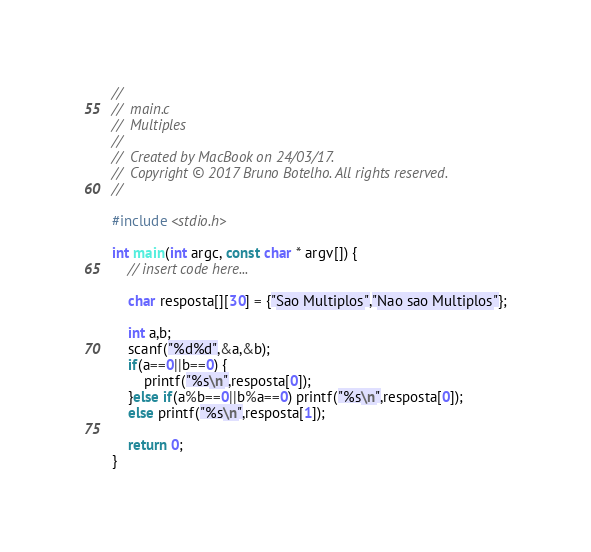Convert code to text. <code><loc_0><loc_0><loc_500><loc_500><_C_>//
//  main.c
//  Multiples
//
//  Created by MacBook on 24/03/17.
//  Copyright © 2017 Bruno Botelho. All rights reserved.
//

#include <stdio.h>

int main(int argc, const char * argv[]) {
    // insert code here...
    
    char resposta[][30] = {"Sao Multiplos","Nao sao Multiplos"};
    
    int a,b;
    scanf("%d%d",&a,&b);
    if(a==0||b==0) {
        printf("%s\n",resposta[0]);
    }else if(a%b==0||b%a==0) printf("%s\n",resposta[0]);
    else printf("%s\n",resposta[1]);
    
    return 0;
}
</code> 